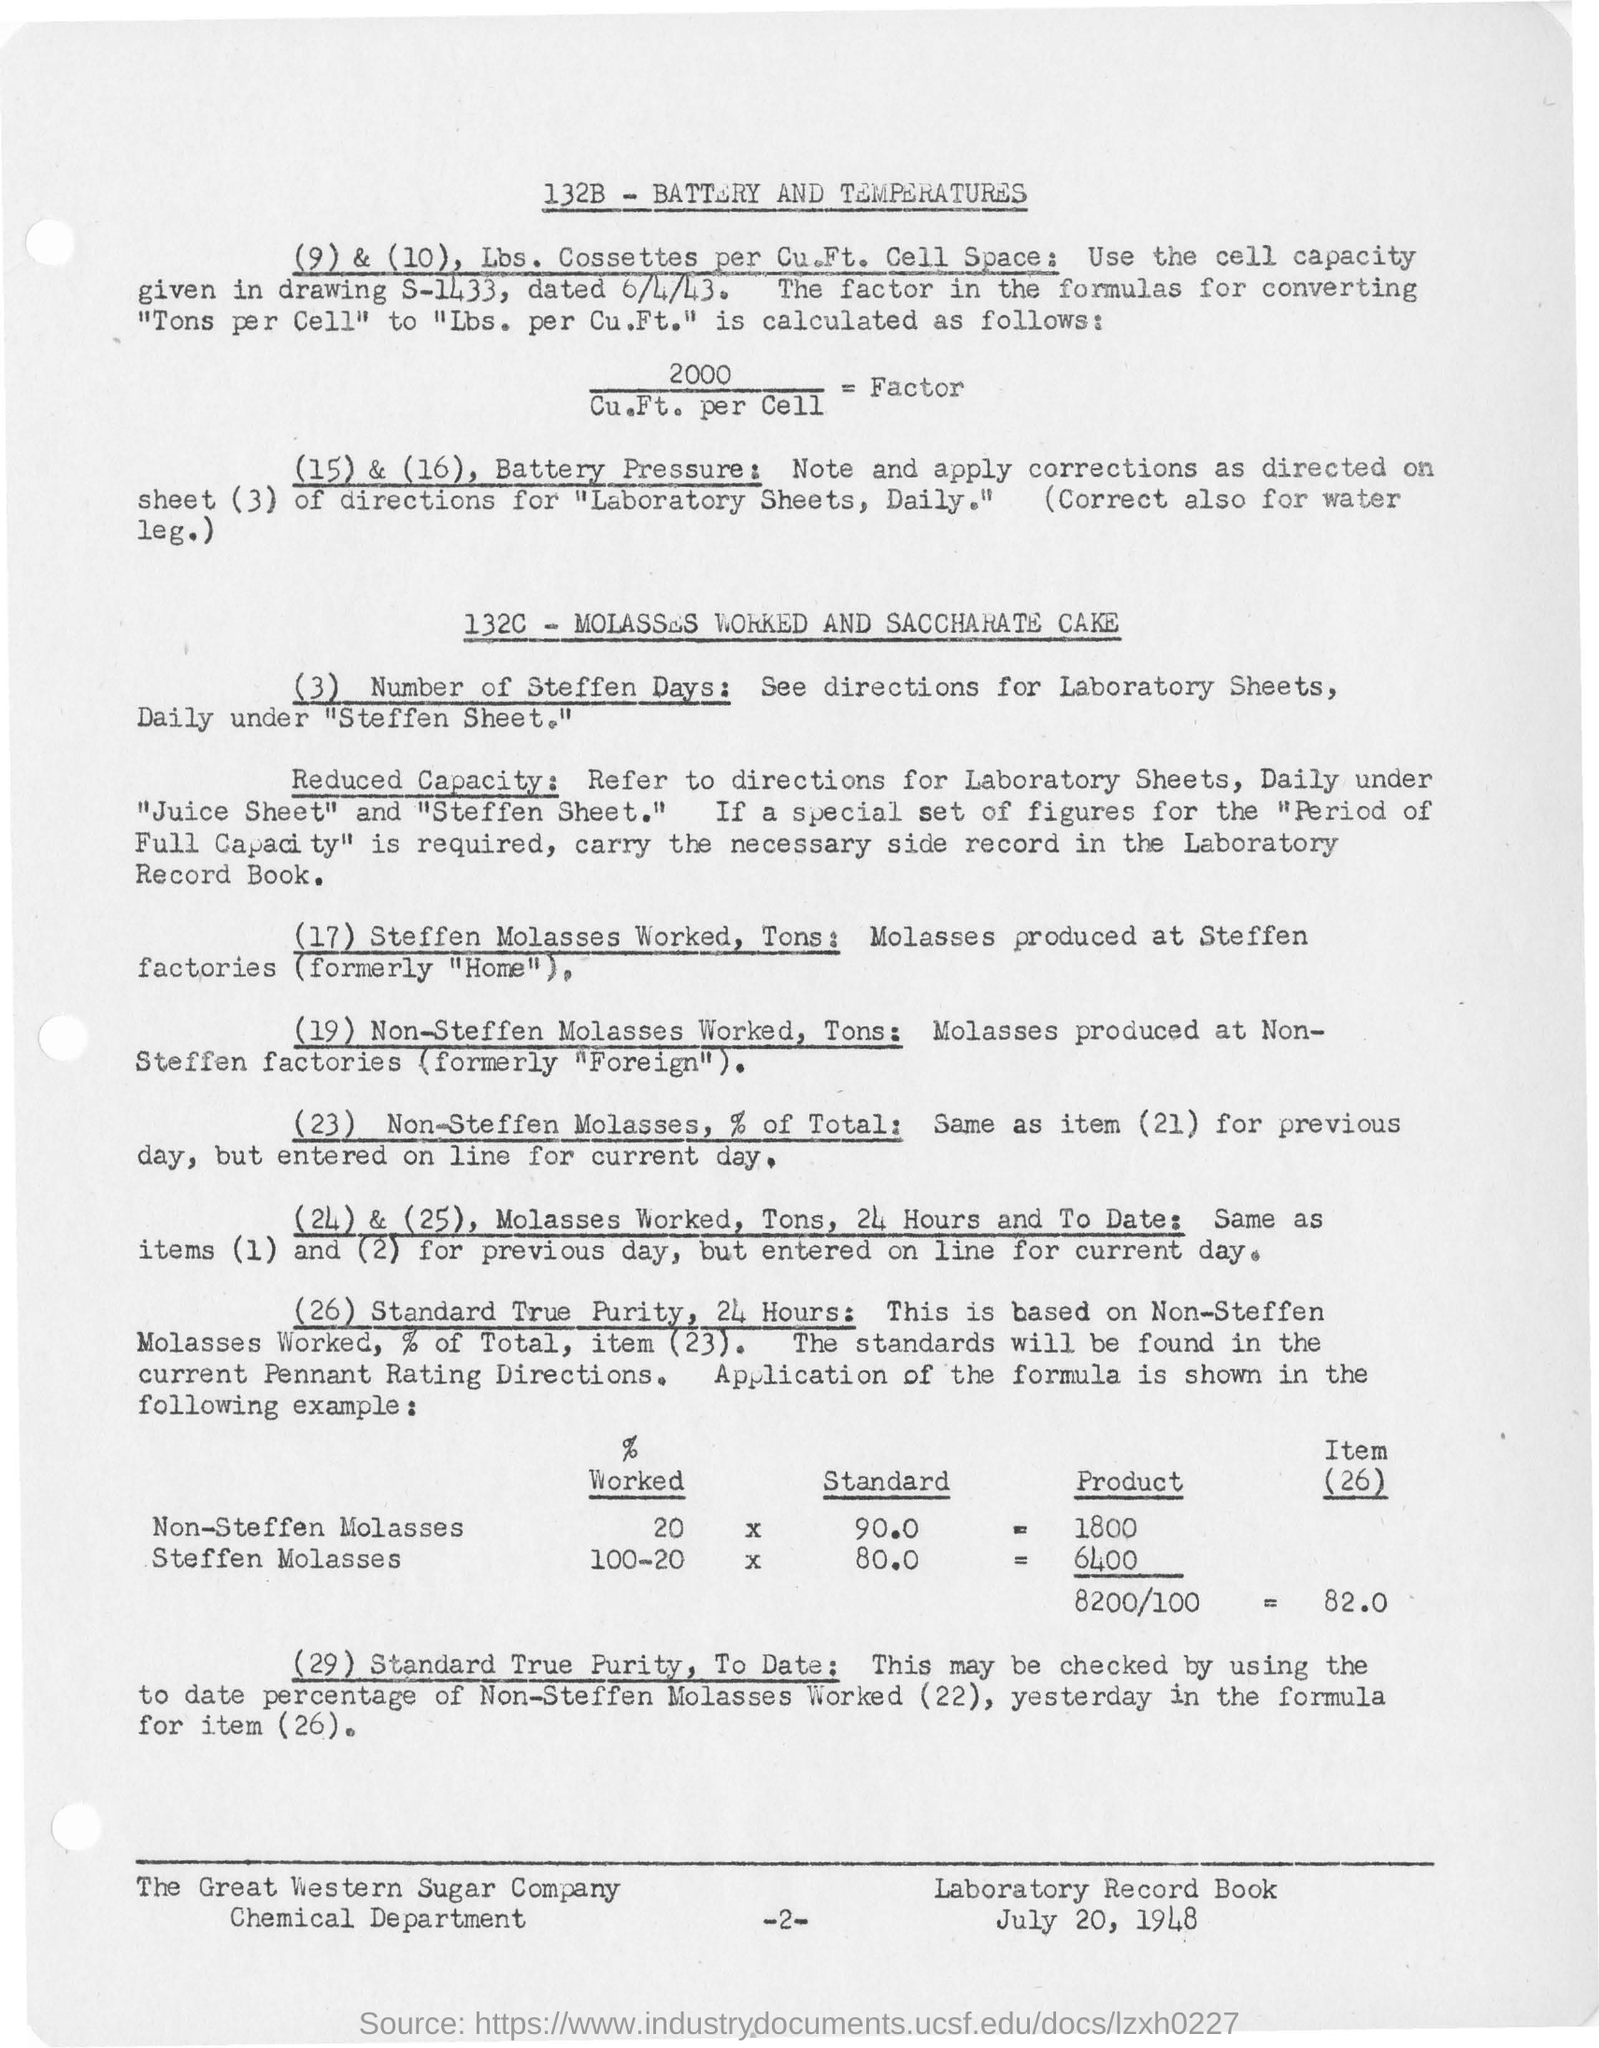What is the drawing number showing the cell capacity?
Your answer should be very brief. S-1433. 